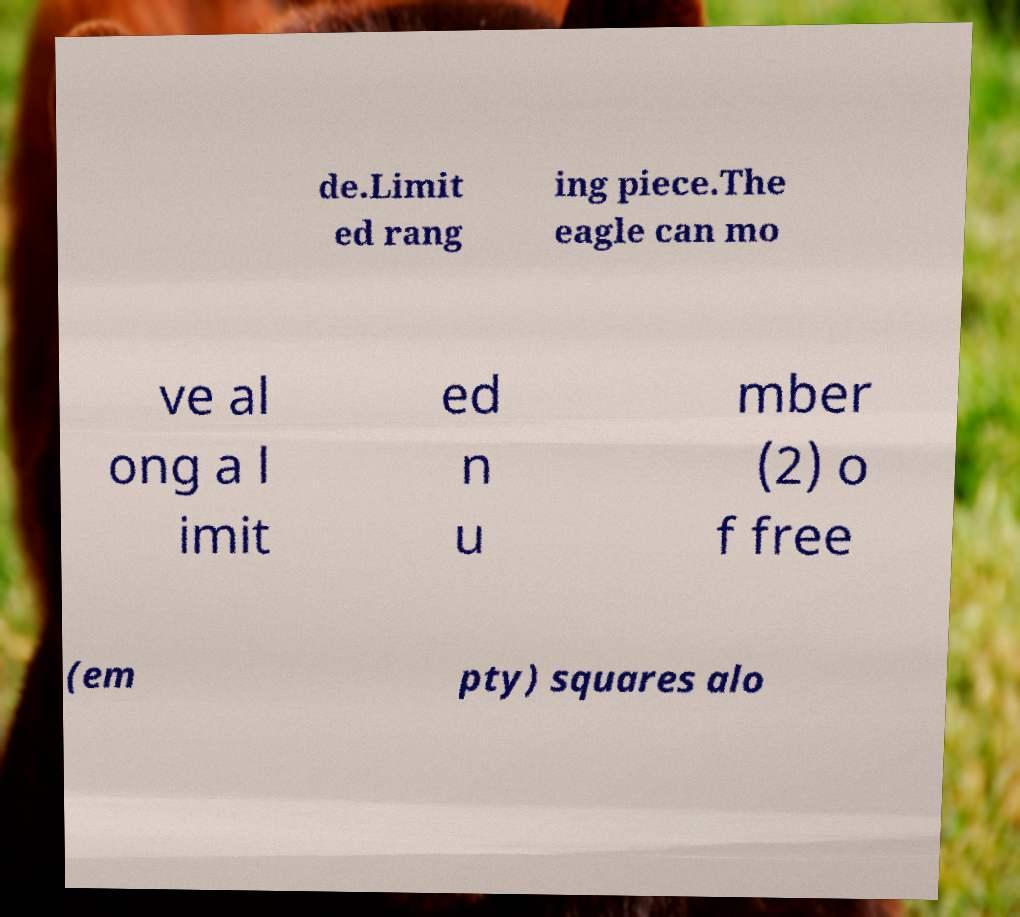Can you read and provide the text displayed in the image?This photo seems to have some interesting text. Can you extract and type it out for me? de.Limit ed rang ing piece.The eagle can mo ve al ong a l imit ed n u mber (2) o f free (em pty) squares alo 